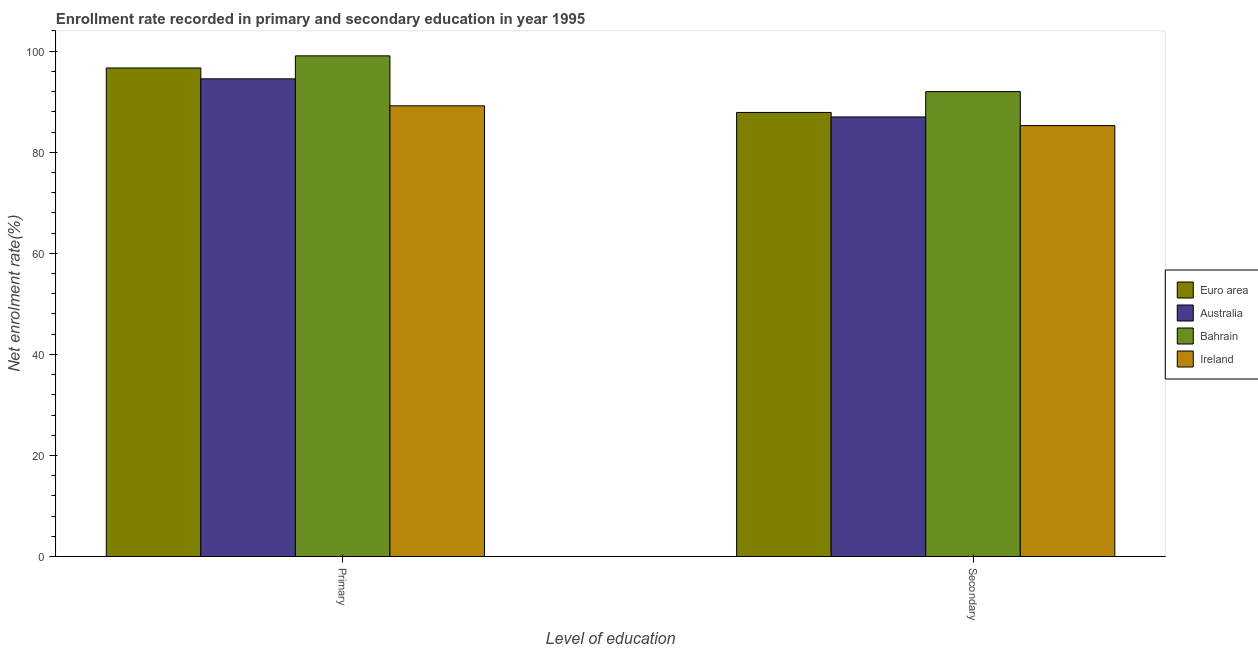How many groups of bars are there?
Make the answer very short. 2. Are the number of bars per tick equal to the number of legend labels?
Your answer should be compact. Yes. What is the label of the 2nd group of bars from the left?
Provide a succinct answer. Secondary. What is the enrollment rate in primary education in Bahrain?
Your answer should be very brief. 99.07. Across all countries, what is the maximum enrollment rate in primary education?
Provide a short and direct response. 99.07. Across all countries, what is the minimum enrollment rate in primary education?
Your response must be concise. 89.19. In which country was the enrollment rate in primary education maximum?
Offer a terse response. Bahrain. In which country was the enrollment rate in secondary education minimum?
Ensure brevity in your answer.  Ireland. What is the total enrollment rate in secondary education in the graph?
Offer a very short reply. 352.14. What is the difference between the enrollment rate in secondary education in Australia and that in Euro area?
Provide a succinct answer. -0.89. What is the difference between the enrollment rate in secondary education in Bahrain and the enrollment rate in primary education in Ireland?
Provide a short and direct response. 2.81. What is the average enrollment rate in primary education per country?
Keep it short and to the point. 94.87. What is the difference between the enrollment rate in primary education and enrollment rate in secondary education in Bahrain?
Keep it short and to the point. 7.07. In how many countries, is the enrollment rate in primary education greater than 76 %?
Ensure brevity in your answer.  4. What is the ratio of the enrollment rate in secondary education in Ireland to that in Australia?
Provide a succinct answer. 0.98. In how many countries, is the enrollment rate in secondary education greater than the average enrollment rate in secondary education taken over all countries?
Your answer should be very brief. 1. What does the 3rd bar from the left in Secondary represents?
Offer a terse response. Bahrain. Are all the bars in the graph horizontal?
Offer a terse response. No. How many countries are there in the graph?
Offer a terse response. 4. What is the difference between two consecutive major ticks on the Y-axis?
Your answer should be very brief. 20. Are the values on the major ticks of Y-axis written in scientific E-notation?
Give a very brief answer. No. How many legend labels are there?
Offer a terse response. 4. What is the title of the graph?
Your response must be concise. Enrollment rate recorded in primary and secondary education in year 1995. Does "High income: OECD" appear as one of the legend labels in the graph?
Provide a short and direct response. No. What is the label or title of the X-axis?
Keep it short and to the point. Level of education. What is the label or title of the Y-axis?
Provide a succinct answer. Net enrolment rate(%). What is the Net enrolment rate(%) of Euro area in Primary?
Make the answer very short. 96.68. What is the Net enrolment rate(%) in Australia in Primary?
Your answer should be very brief. 94.53. What is the Net enrolment rate(%) of Bahrain in Primary?
Your answer should be very brief. 99.07. What is the Net enrolment rate(%) in Ireland in Primary?
Ensure brevity in your answer.  89.19. What is the Net enrolment rate(%) of Euro area in Secondary?
Ensure brevity in your answer.  87.88. What is the Net enrolment rate(%) of Australia in Secondary?
Your answer should be compact. 86.99. What is the Net enrolment rate(%) in Bahrain in Secondary?
Offer a terse response. 92. What is the Net enrolment rate(%) of Ireland in Secondary?
Your answer should be very brief. 85.27. Across all Level of education, what is the maximum Net enrolment rate(%) in Euro area?
Provide a succinct answer. 96.68. Across all Level of education, what is the maximum Net enrolment rate(%) of Australia?
Offer a very short reply. 94.53. Across all Level of education, what is the maximum Net enrolment rate(%) of Bahrain?
Offer a very short reply. 99.07. Across all Level of education, what is the maximum Net enrolment rate(%) of Ireland?
Give a very brief answer. 89.19. Across all Level of education, what is the minimum Net enrolment rate(%) of Euro area?
Ensure brevity in your answer.  87.88. Across all Level of education, what is the minimum Net enrolment rate(%) in Australia?
Offer a terse response. 86.99. Across all Level of education, what is the minimum Net enrolment rate(%) in Bahrain?
Make the answer very short. 92. Across all Level of education, what is the minimum Net enrolment rate(%) in Ireland?
Your answer should be compact. 85.27. What is the total Net enrolment rate(%) in Euro area in the graph?
Offer a terse response. 184.56. What is the total Net enrolment rate(%) in Australia in the graph?
Your answer should be very brief. 181.51. What is the total Net enrolment rate(%) of Bahrain in the graph?
Keep it short and to the point. 191.08. What is the total Net enrolment rate(%) in Ireland in the graph?
Offer a terse response. 174.46. What is the difference between the Net enrolment rate(%) in Euro area in Primary and that in Secondary?
Offer a very short reply. 8.8. What is the difference between the Net enrolment rate(%) of Australia in Primary and that in Secondary?
Make the answer very short. 7.54. What is the difference between the Net enrolment rate(%) of Bahrain in Primary and that in Secondary?
Your answer should be compact. 7.07. What is the difference between the Net enrolment rate(%) in Ireland in Primary and that in Secondary?
Your response must be concise. 3.91. What is the difference between the Net enrolment rate(%) in Euro area in Primary and the Net enrolment rate(%) in Australia in Secondary?
Make the answer very short. 9.69. What is the difference between the Net enrolment rate(%) of Euro area in Primary and the Net enrolment rate(%) of Bahrain in Secondary?
Your answer should be very brief. 4.68. What is the difference between the Net enrolment rate(%) in Euro area in Primary and the Net enrolment rate(%) in Ireland in Secondary?
Your answer should be very brief. 11.4. What is the difference between the Net enrolment rate(%) in Australia in Primary and the Net enrolment rate(%) in Bahrain in Secondary?
Offer a very short reply. 2.53. What is the difference between the Net enrolment rate(%) of Australia in Primary and the Net enrolment rate(%) of Ireland in Secondary?
Ensure brevity in your answer.  9.25. What is the difference between the Net enrolment rate(%) of Bahrain in Primary and the Net enrolment rate(%) of Ireland in Secondary?
Provide a short and direct response. 13.8. What is the average Net enrolment rate(%) of Euro area per Level of education?
Offer a terse response. 92.28. What is the average Net enrolment rate(%) in Australia per Level of education?
Offer a very short reply. 90.76. What is the average Net enrolment rate(%) in Bahrain per Level of education?
Your answer should be compact. 95.54. What is the average Net enrolment rate(%) in Ireland per Level of education?
Give a very brief answer. 87.23. What is the difference between the Net enrolment rate(%) of Euro area and Net enrolment rate(%) of Australia in Primary?
Offer a very short reply. 2.15. What is the difference between the Net enrolment rate(%) of Euro area and Net enrolment rate(%) of Bahrain in Primary?
Your response must be concise. -2.4. What is the difference between the Net enrolment rate(%) in Euro area and Net enrolment rate(%) in Ireland in Primary?
Provide a short and direct response. 7.49. What is the difference between the Net enrolment rate(%) in Australia and Net enrolment rate(%) in Bahrain in Primary?
Provide a succinct answer. -4.55. What is the difference between the Net enrolment rate(%) in Australia and Net enrolment rate(%) in Ireland in Primary?
Ensure brevity in your answer.  5.34. What is the difference between the Net enrolment rate(%) of Bahrain and Net enrolment rate(%) of Ireland in Primary?
Your response must be concise. 9.89. What is the difference between the Net enrolment rate(%) in Euro area and Net enrolment rate(%) in Australia in Secondary?
Provide a short and direct response. 0.89. What is the difference between the Net enrolment rate(%) in Euro area and Net enrolment rate(%) in Bahrain in Secondary?
Provide a succinct answer. -4.12. What is the difference between the Net enrolment rate(%) of Euro area and Net enrolment rate(%) of Ireland in Secondary?
Offer a terse response. 2.6. What is the difference between the Net enrolment rate(%) in Australia and Net enrolment rate(%) in Bahrain in Secondary?
Ensure brevity in your answer.  -5.01. What is the difference between the Net enrolment rate(%) in Australia and Net enrolment rate(%) in Ireland in Secondary?
Ensure brevity in your answer.  1.71. What is the difference between the Net enrolment rate(%) in Bahrain and Net enrolment rate(%) in Ireland in Secondary?
Provide a short and direct response. 6.73. What is the ratio of the Net enrolment rate(%) of Euro area in Primary to that in Secondary?
Make the answer very short. 1.1. What is the ratio of the Net enrolment rate(%) in Australia in Primary to that in Secondary?
Your response must be concise. 1.09. What is the ratio of the Net enrolment rate(%) of Ireland in Primary to that in Secondary?
Keep it short and to the point. 1.05. What is the difference between the highest and the second highest Net enrolment rate(%) of Euro area?
Provide a short and direct response. 8.8. What is the difference between the highest and the second highest Net enrolment rate(%) of Australia?
Ensure brevity in your answer.  7.54. What is the difference between the highest and the second highest Net enrolment rate(%) in Bahrain?
Keep it short and to the point. 7.07. What is the difference between the highest and the second highest Net enrolment rate(%) in Ireland?
Offer a very short reply. 3.91. What is the difference between the highest and the lowest Net enrolment rate(%) in Euro area?
Keep it short and to the point. 8.8. What is the difference between the highest and the lowest Net enrolment rate(%) in Australia?
Give a very brief answer. 7.54. What is the difference between the highest and the lowest Net enrolment rate(%) of Bahrain?
Make the answer very short. 7.07. What is the difference between the highest and the lowest Net enrolment rate(%) in Ireland?
Provide a short and direct response. 3.91. 